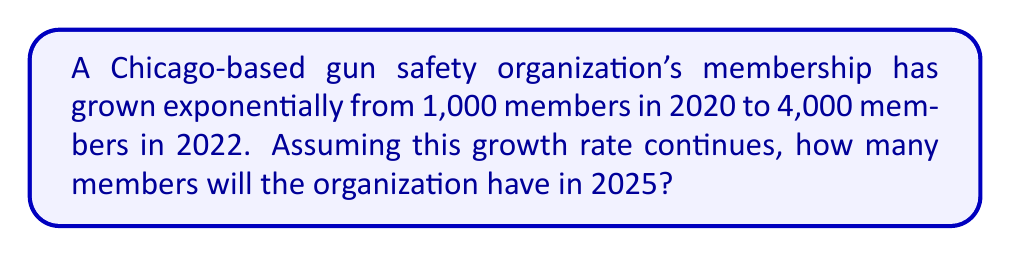Give your solution to this math problem. To solve this problem, we need to use the exponential growth formula:

$$A = P(1 + r)^t$$

Where:
$A$ = Final amount
$P$ = Initial amount
$r$ = Growth rate (in decimal form)
$t$ = Time period

Step 1: Determine the growth rate
We know that:
$P = 1,000$ (initial members in 2020)
$A = 4,000$ (members in 2022)
$t = 2$ years (from 2020 to 2022)

Substituting these values into the formula:
$$4,000 = 1,000(1 + r)^2$$

Step 2: Solve for $r$
$$4 = (1 + r)^2$$
$$\sqrt{4} = 1 + r$$
$$2 = 1 + r$$
$$r = 1 = 100\%$$

The growth rate is 100% per year.

Step 3: Calculate membership in 2025
Now we use the same formula to find the membership in 2025:
$P = 1,000$ (initial members in 2020)
$r = 1$ (100% growth rate)
$t = 5$ (years from 2020 to 2025)

$$A = 1,000(1 + 1)^5 = 1,000(2)^5 = 1,000 \times 32 = 32,000$$

Therefore, the organization will have 32,000 members in 2025.
Answer: 32,000 members 